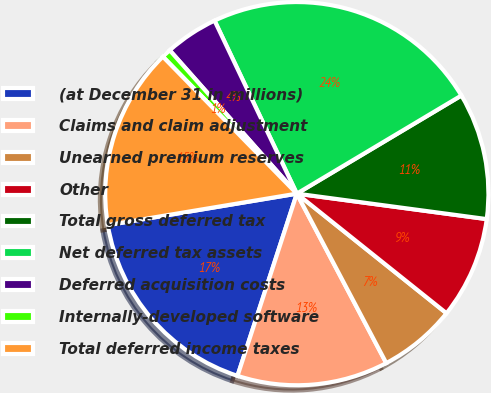Convert chart. <chart><loc_0><loc_0><loc_500><loc_500><pie_chart><fcel>(at December 31 in millions)<fcel>Claims and claim adjustment<fcel>Unearned premium reserves<fcel>Other<fcel>Total gross deferred tax<fcel>Net deferred tax assets<fcel>Deferred acquisition costs<fcel>Internally-developed software<fcel>Total deferred income taxes<nl><fcel>17.37%<fcel>12.74%<fcel>6.54%<fcel>8.61%<fcel>10.68%<fcel>23.51%<fcel>4.48%<fcel>0.78%<fcel>15.3%<nl></chart> 